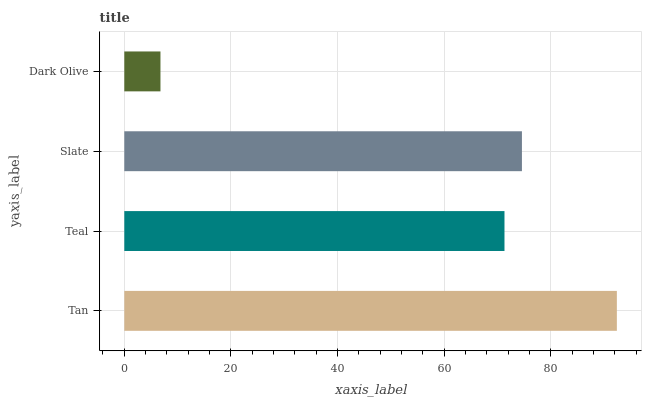Is Dark Olive the minimum?
Answer yes or no. Yes. Is Tan the maximum?
Answer yes or no. Yes. Is Teal the minimum?
Answer yes or no. No. Is Teal the maximum?
Answer yes or no. No. Is Tan greater than Teal?
Answer yes or no. Yes. Is Teal less than Tan?
Answer yes or no. Yes. Is Teal greater than Tan?
Answer yes or no. No. Is Tan less than Teal?
Answer yes or no. No. Is Slate the high median?
Answer yes or no. Yes. Is Teal the low median?
Answer yes or no. Yes. Is Dark Olive the high median?
Answer yes or no. No. Is Tan the low median?
Answer yes or no. No. 